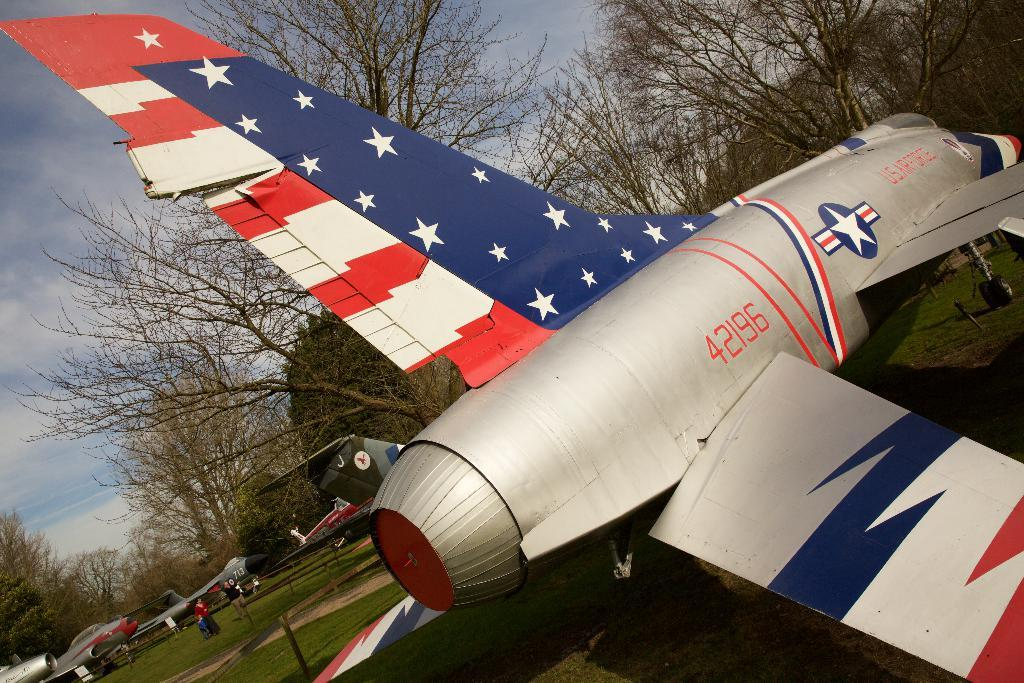<image>
Create a compact narrative representing the image presented. Jet 42196 is parked outside with other planes. 